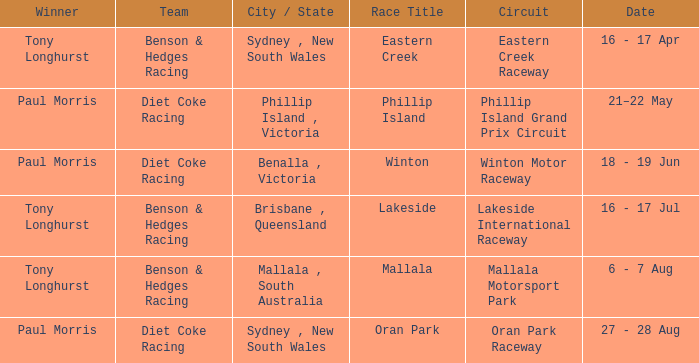When was the Mallala race held? 6 - 7 Aug. 